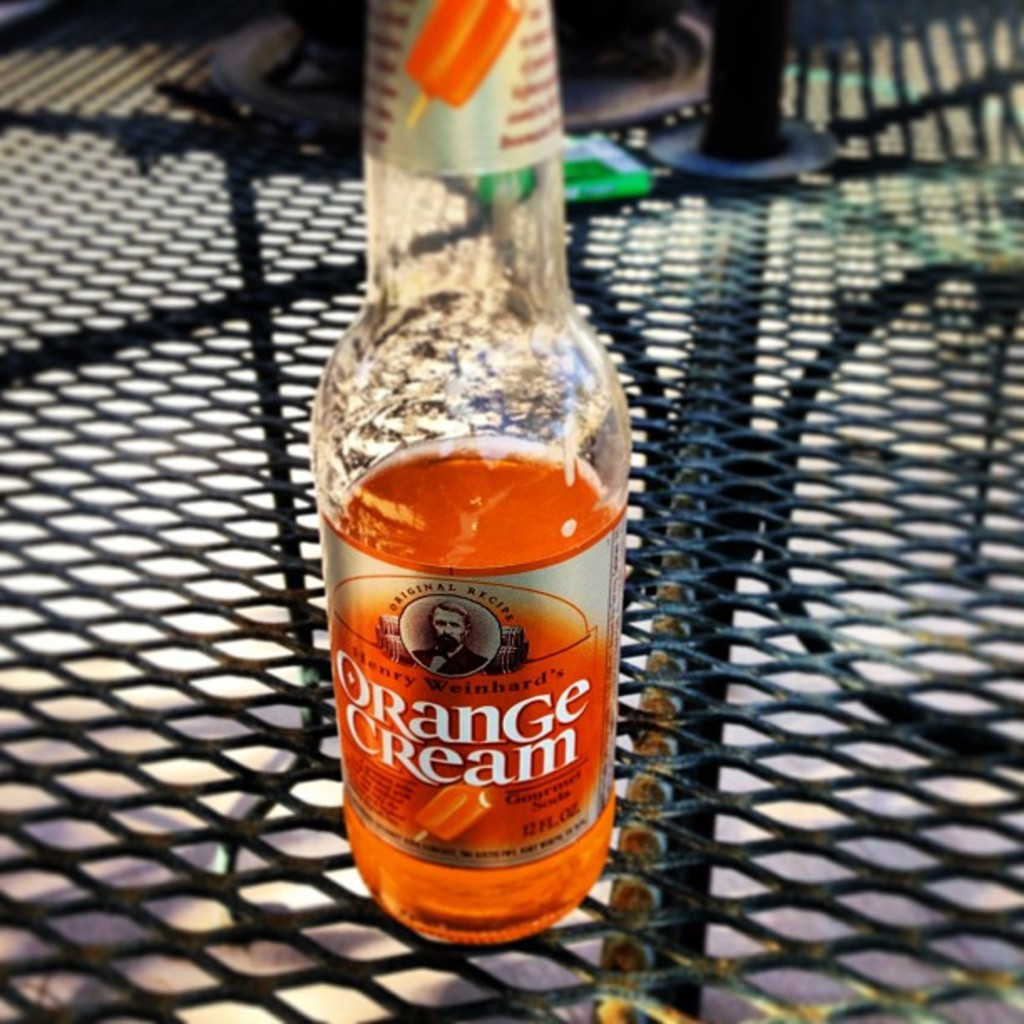Provide a one-sentence caption for the provided image. A tantalizing half-full bottle of Henry Weinhard's Orange Cream soda basks in the warm glow of sunlight atop a metal mesh table, inviting a refreshing sip. 